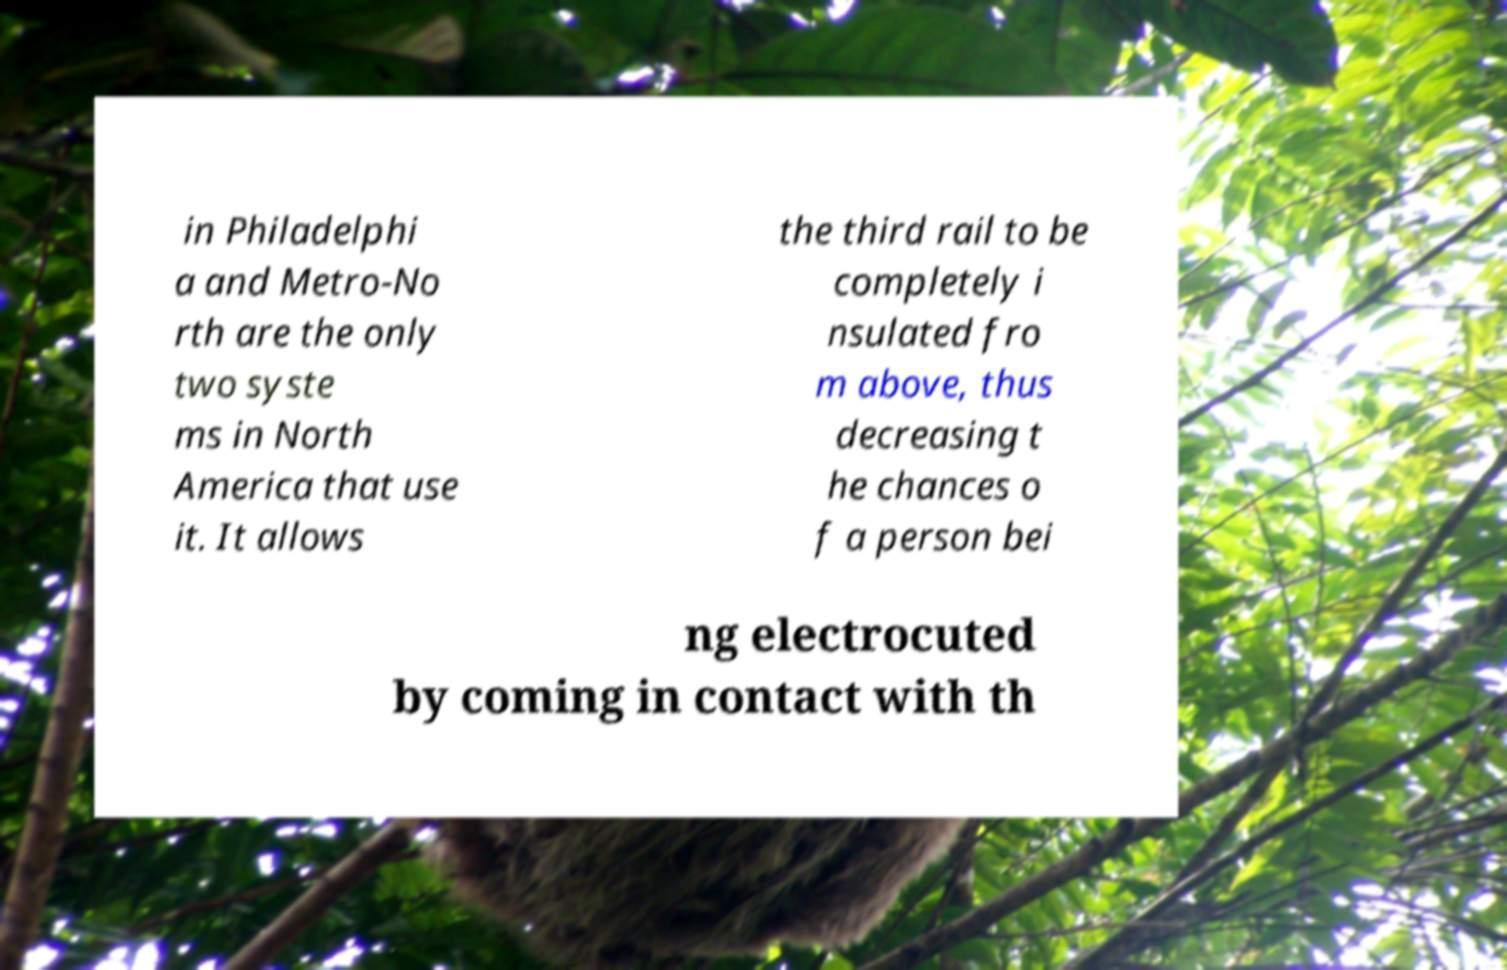Could you assist in decoding the text presented in this image and type it out clearly? in Philadelphi a and Metro-No rth are the only two syste ms in North America that use it. It allows the third rail to be completely i nsulated fro m above, thus decreasing t he chances o f a person bei ng electrocuted by coming in contact with th 